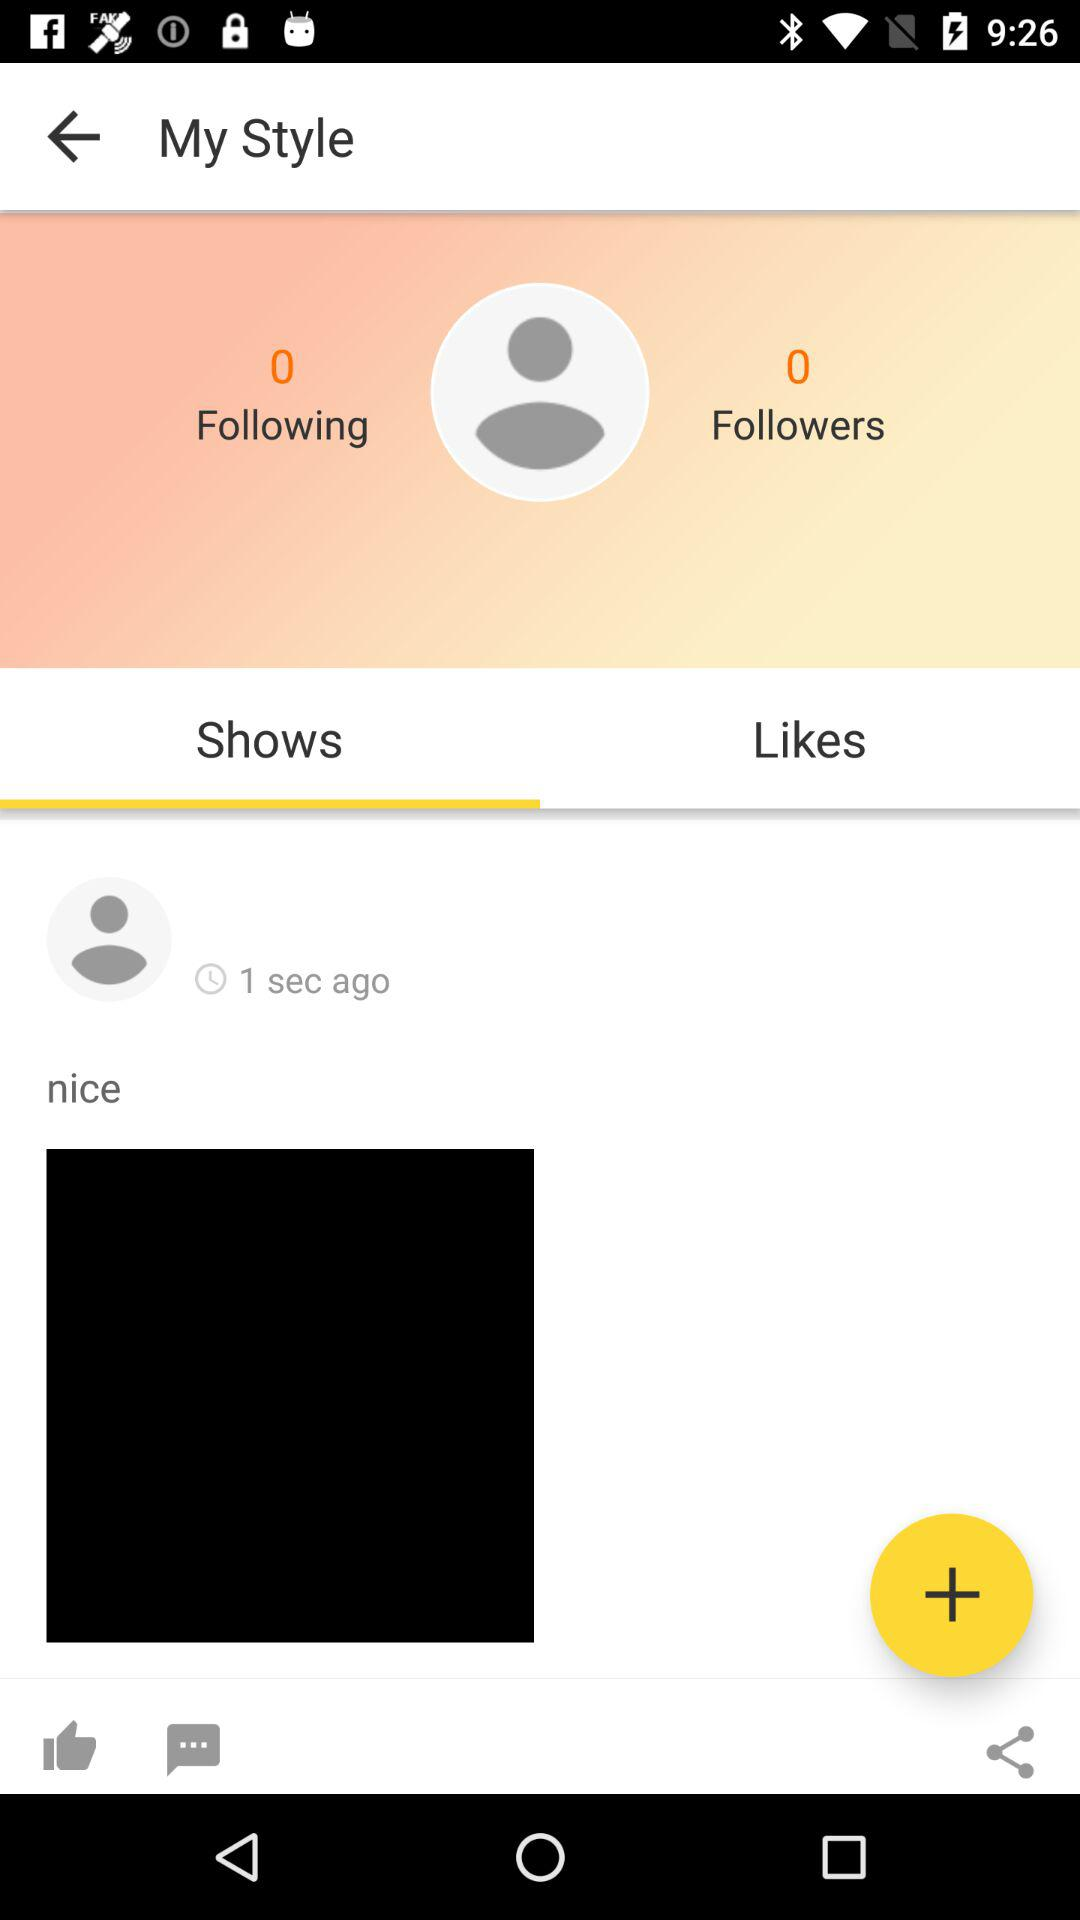How many seconds ago was the post made?
Answer the question using a single word or phrase. 1 